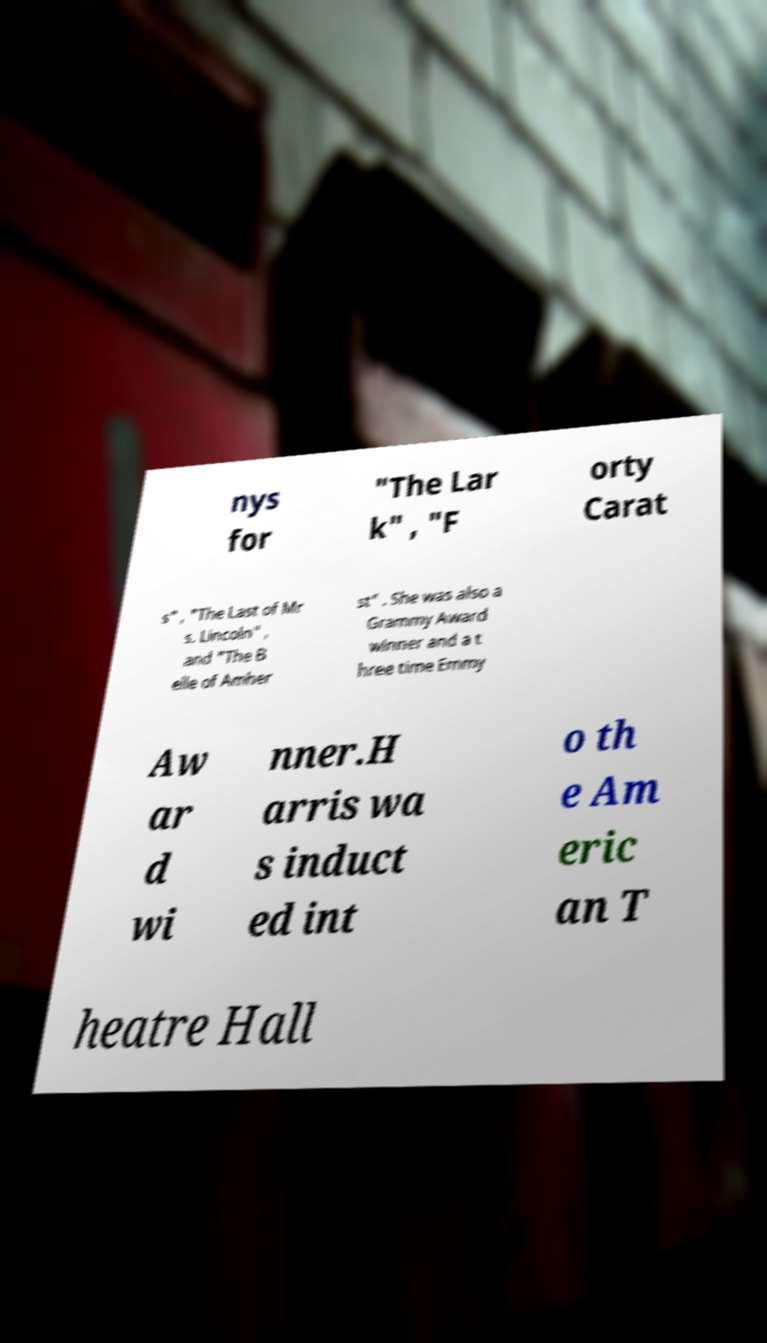For documentation purposes, I need the text within this image transcribed. Could you provide that? nys for "The Lar k" , "F orty Carat s" , "The Last of Mr s. Lincoln" , and "The B elle of Amher st" . She was also a Grammy Award winner and a t hree time Emmy Aw ar d wi nner.H arris wa s induct ed int o th e Am eric an T heatre Hall 